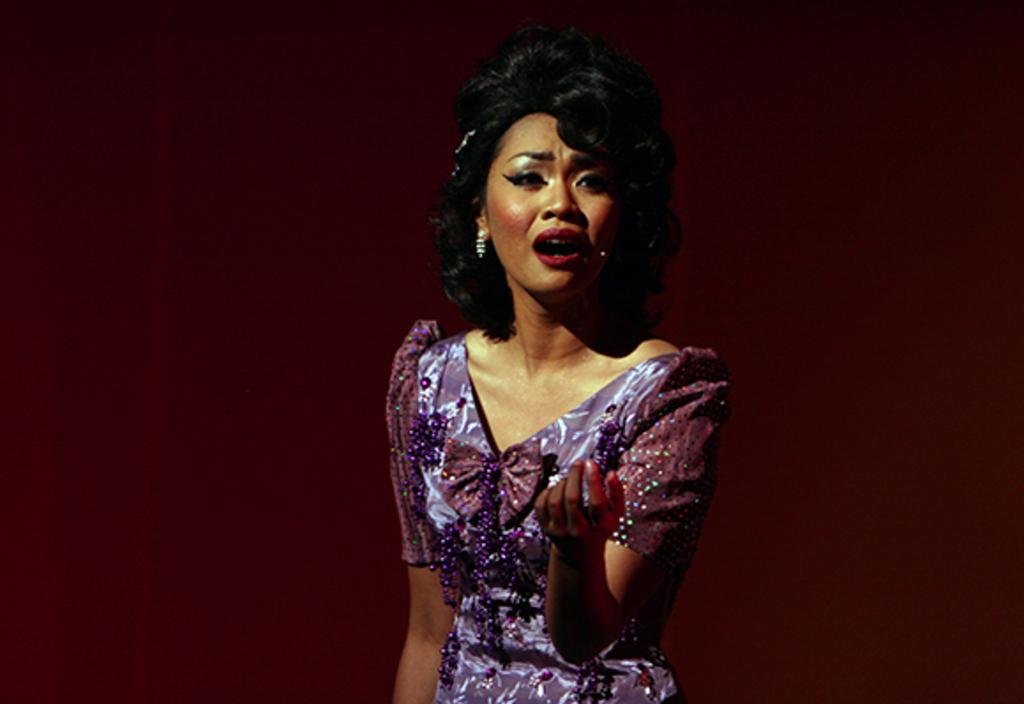Who is the main subject in the image? There is a lady in the center of the image. What is the lady doing in the image? The lady is standing and talking. What can be seen in the background of the image? There is a wall in the background of the image. What type of fan is visible in the image? There is no fan present in the image. What position does the lady hold in the image? The lady is standing, but there is no indication of her position or role in the image. 